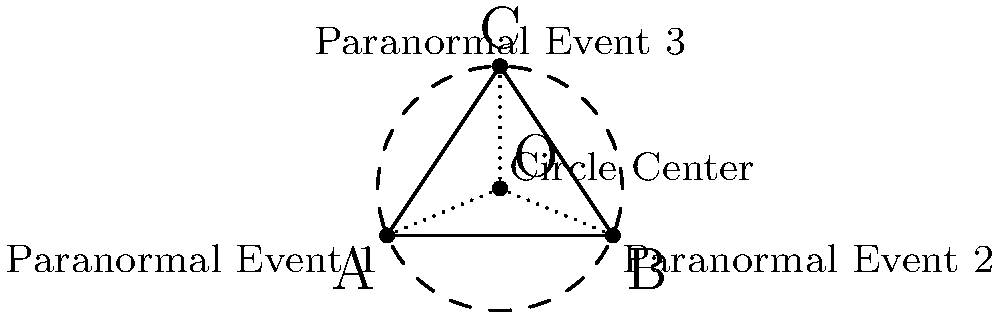In the haunted town of Shadowville, three paranormal events have been reported at different locations. To determine the epicenter of these supernatural occurrences, you decide to find the center of a circle passing through these three points. Given the coordinates of the events: A(0,0), B(4,0), and C(2,3), what are the coordinates of the circle's center (O)? To find the center of the circle passing through three points, we'll use the following steps:

1) The center of the circle is the intersection point of the perpendicular bisectors of any two sides of the triangle formed by the three points.

2) Let's choose sides AB and BC. We need to find their midpoints first:
   Midpoint of AB: $M_{AB} = (\frac{0+4}{2}, \frac{0+0}{2}) = (2,0)$
   Midpoint of BC: $M_{BC} = (\frac{4+2}{2}, \frac{0+3}{2}) = (3,1.5)$

3) Now, we need to find the slopes of AB and BC:
   Slope of AB: $m_{AB} = \frac{0-0}{4-0} = 0$
   Slope of BC: $m_{BC} = \frac{3-0}{2-4} = -1.5$

4) The slopes of the perpendicular bisectors will be the negative reciprocals:
   Slope of perpendicular bisector of AB: $m_{1} = \text{undefined}$ (vertical line)
   Slope of perpendicular bisector of BC: $m_{2} = \frac{1}{1.5} = \frac{2}{3}$

5) We can now write equations for these perpendicular bisectors:
   Line 1 (perpendicular to AB): $x = 2$
   Line 2 (perpendicular to BC): $y - 1.5 = \frac{2}{3}(x - 3)$

6) To find the intersection point (the center O), we solve these equations:
   $x = 2$
   $y - 1.5 = \frac{2}{3}(2 - 3) = -\frac{2}{3}$
   $y = 1.5 - \frac{2}{3} = \frac{5}{6}$

Therefore, the coordinates of the circle's center O are $(2, \frac{5}{6})$.
Answer: $(2, \frac{5}{6})$ 